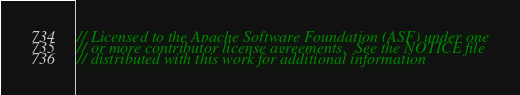Convert code to text. <code><loc_0><loc_0><loc_500><loc_500><_Rust_>// Licensed to the Apache Software Foundation (ASF) under one
// or more contributor license agreements.  See the NOTICE file
// distributed with this work for additional information</code> 